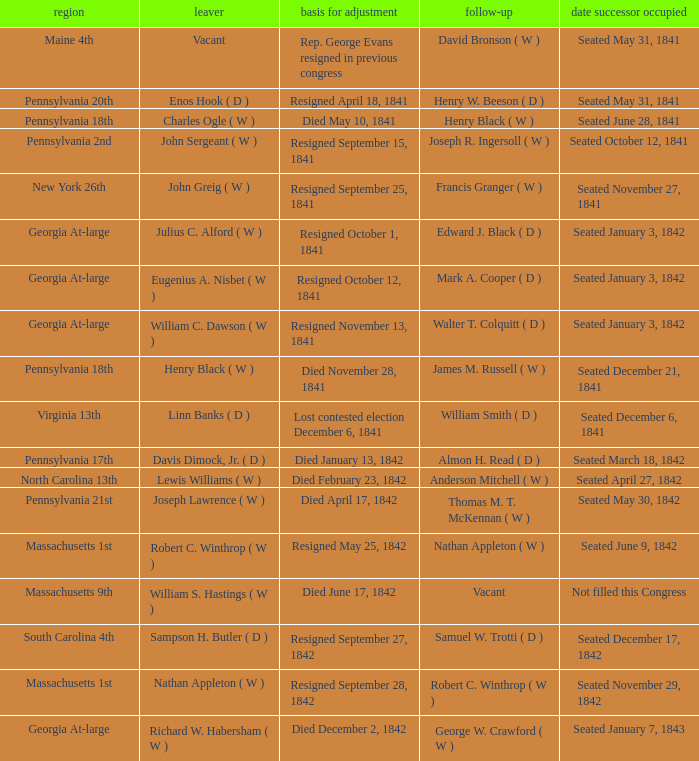Name the date successor seated for pennsylvania 17th Seated March 18, 1842. 